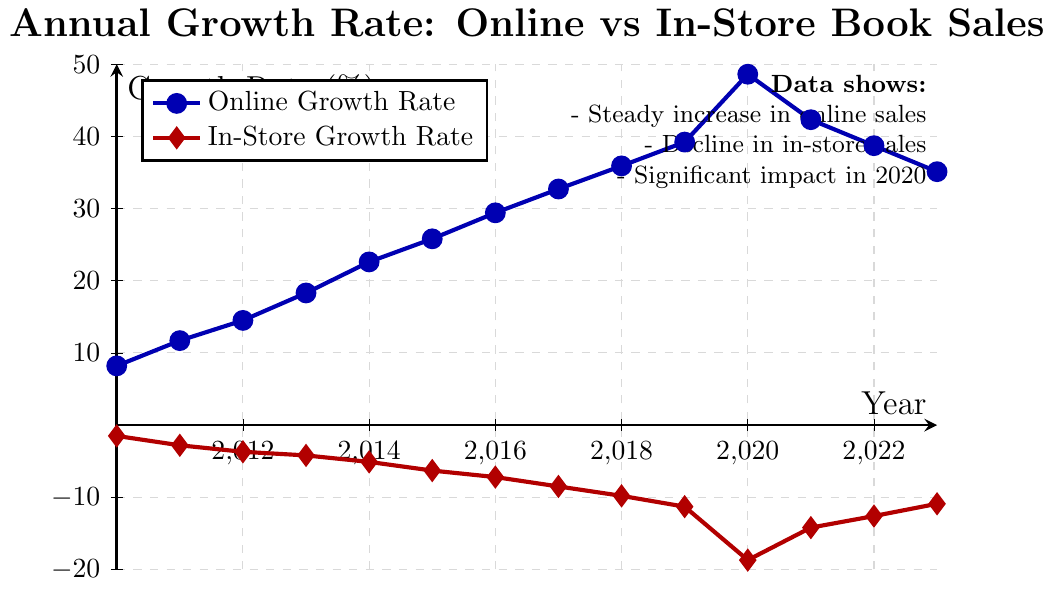Which year had the highest online growth rate? By looking at the plot, we identify the highest point on the blue line representing online growth rate. The peak is at the year 2020, where the growth rate reaches 48.6%.
Answer: 2020 What is the difference in growth rates between online and in-store sales in 2015? Locate the year 2015 on the chart and identify the growth rates for online and in-store sales. The online growth rate is 25.8%, while the in-store growth rate is -6.3%. The difference is 25.8 - (-6.3) = 32.1%.
Answer: 32.1 How did the growth rate of in-store sales change from 2019 to 2020? Identify the growth rate for in-store sales in 2019 and 2020. In 2019, it was -11.3%, and in 2020, it was -18.7%. The change is -18.7 - (-11.3) = -7.4%.
Answer: Decreased by 7.4% By how much did the online growth rate decline from 2020 to 2023? Identify the online growth rates for 2020 and 2023. For 2020, it was 48.6%, and for 2023, it was 35.1%. The decline is 48.6 - 35.1 = 13.5%.
Answer: 13.5 Which year shows the sharpest decline in in-store growth rate? Examine the red line for the largest downward movement between two consecutive years. The sharpest decline occurs between 2019 and 2020, where the rate drops from -11.3% to -18.7%.
Answer: 2020 What is the average growth rate of online sales from 2015 to 2017? Identify the online growth rates for 2015, 2016, and 2017. The rates are 25.8%, 29.4%, and 32.7% respectively. The average is (25.8 + 29.4 + 32.7) / 3 = 29.3%.
Answer: 29.3 Compare the online growth rates in 2018 and 2022. Which one is higher? Find the online growth rate for 2018, which is 35.9%, and for 2022, which is 38.7%. The comparison shows that 2022 had a higher online growth rate.
Answer: 2022 What's the visual difference in the markers for online versus in-store growth rates? Online growth rates are represented by blue circles, while in-store growth rates are represented by red diamonds.
Answer: Blue circles and red diamonds Which year experienced both the highest online growth rate and the lowest in-store growth rate simultaneously? Look for the year with the highest point on the blue line and the lowest point on the red line. Both occur in 2020.
Answer: 2020 